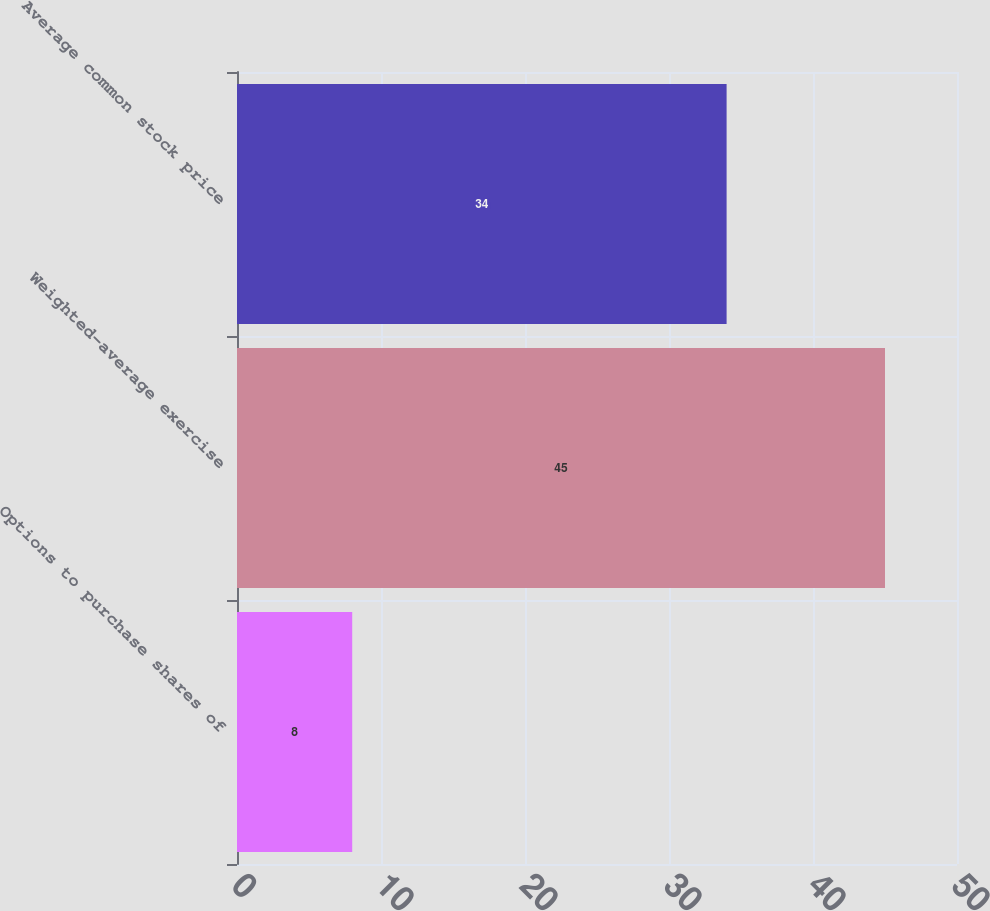Convert chart. <chart><loc_0><loc_0><loc_500><loc_500><bar_chart><fcel>Options to purchase shares of<fcel>Weighted-average exercise<fcel>Average common stock price<nl><fcel>8<fcel>45<fcel>34<nl></chart> 